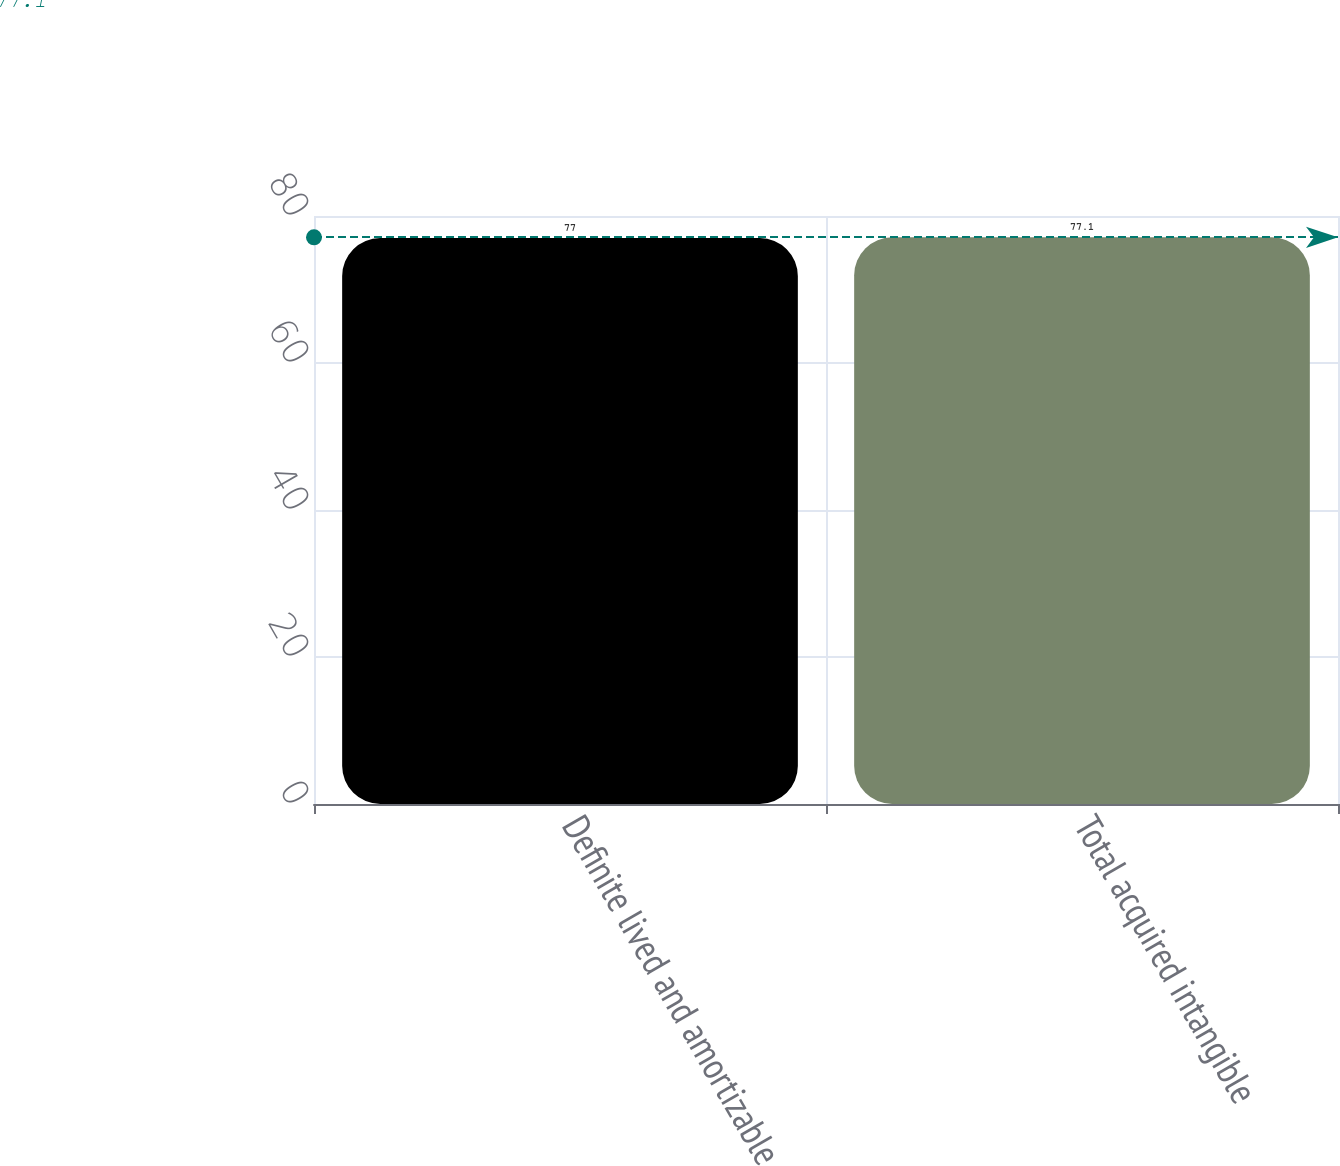Convert chart. <chart><loc_0><loc_0><loc_500><loc_500><bar_chart><fcel>Definite lived and amortizable<fcel>Total acquired intangible<nl><fcel>77<fcel>77.1<nl></chart> 